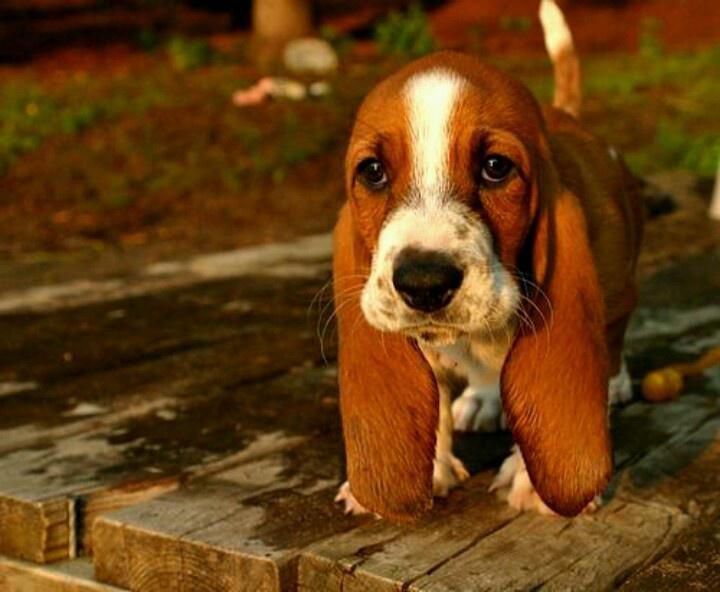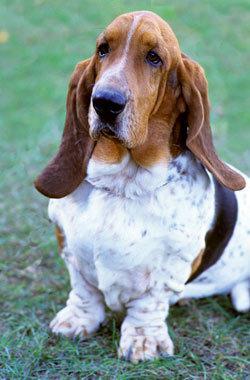The first image is the image on the left, the second image is the image on the right. Considering the images on both sides, is "One of the basset hounds is sitting in the grass." valid? Answer yes or no. Yes. The first image is the image on the left, the second image is the image on the right. For the images displayed, is the sentence "One image has no less than two dogs in it." factually correct? Answer yes or no. No. 